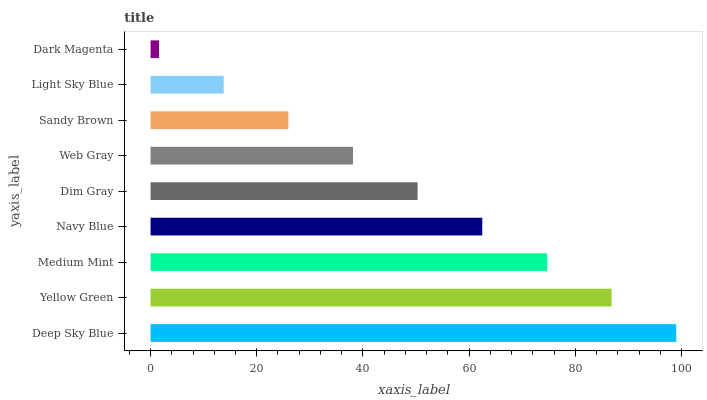Is Dark Magenta the minimum?
Answer yes or no. Yes. Is Deep Sky Blue the maximum?
Answer yes or no. Yes. Is Yellow Green the minimum?
Answer yes or no. No. Is Yellow Green the maximum?
Answer yes or no. No. Is Deep Sky Blue greater than Yellow Green?
Answer yes or no. Yes. Is Yellow Green less than Deep Sky Blue?
Answer yes or no. Yes. Is Yellow Green greater than Deep Sky Blue?
Answer yes or no. No. Is Deep Sky Blue less than Yellow Green?
Answer yes or no. No. Is Dim Gray the high median?
Answer yes or no. Yes. Is Dim Gray the low median?
Answer yes or no. Yes. Is Dark Magenta the high median?
Answer yes or no. No. Is Sandy Brown the low median?
Answer yes or no. No. 